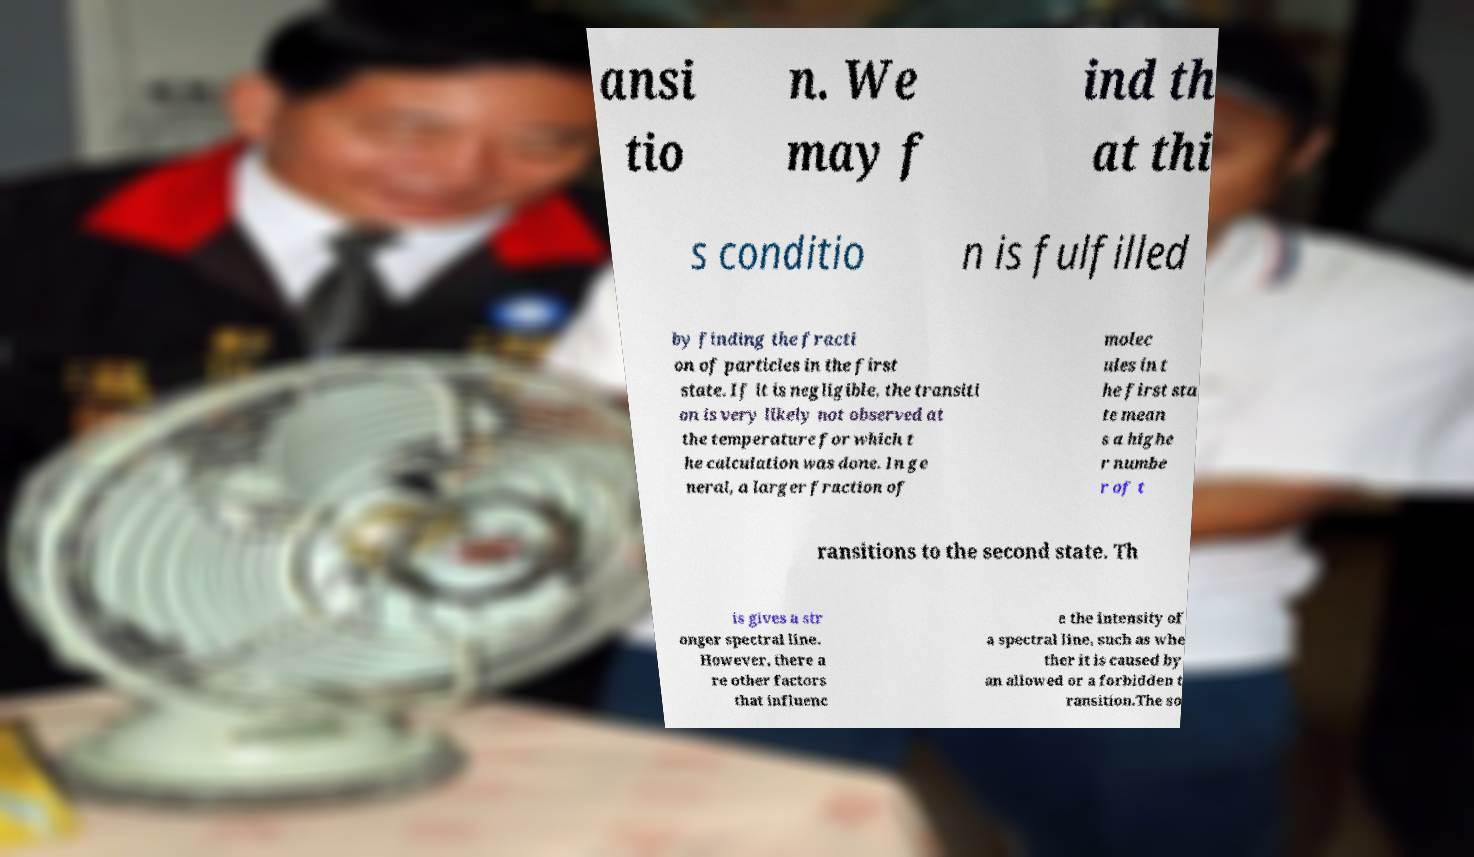Could you assist in decoding the text presented in this image and type it out clearly? ansi tio n. We may f ind th at thi s conditio n is fulfilled by finding the fracti on of particles in the first state. If it is negligible, the transiti on is very likely not observed at the temperature for which t he calculation was done. In ge neral, a larger fraction of molec ules in t he first sta te mean s a highe r numbe r of t ransitions to the second state. Th is gives a str onger spectral line. However, there a re other factors that influenc e the intensity of a spectral line, such as whe ther it is caused by an allowed or a forbidden t ransition.The so 